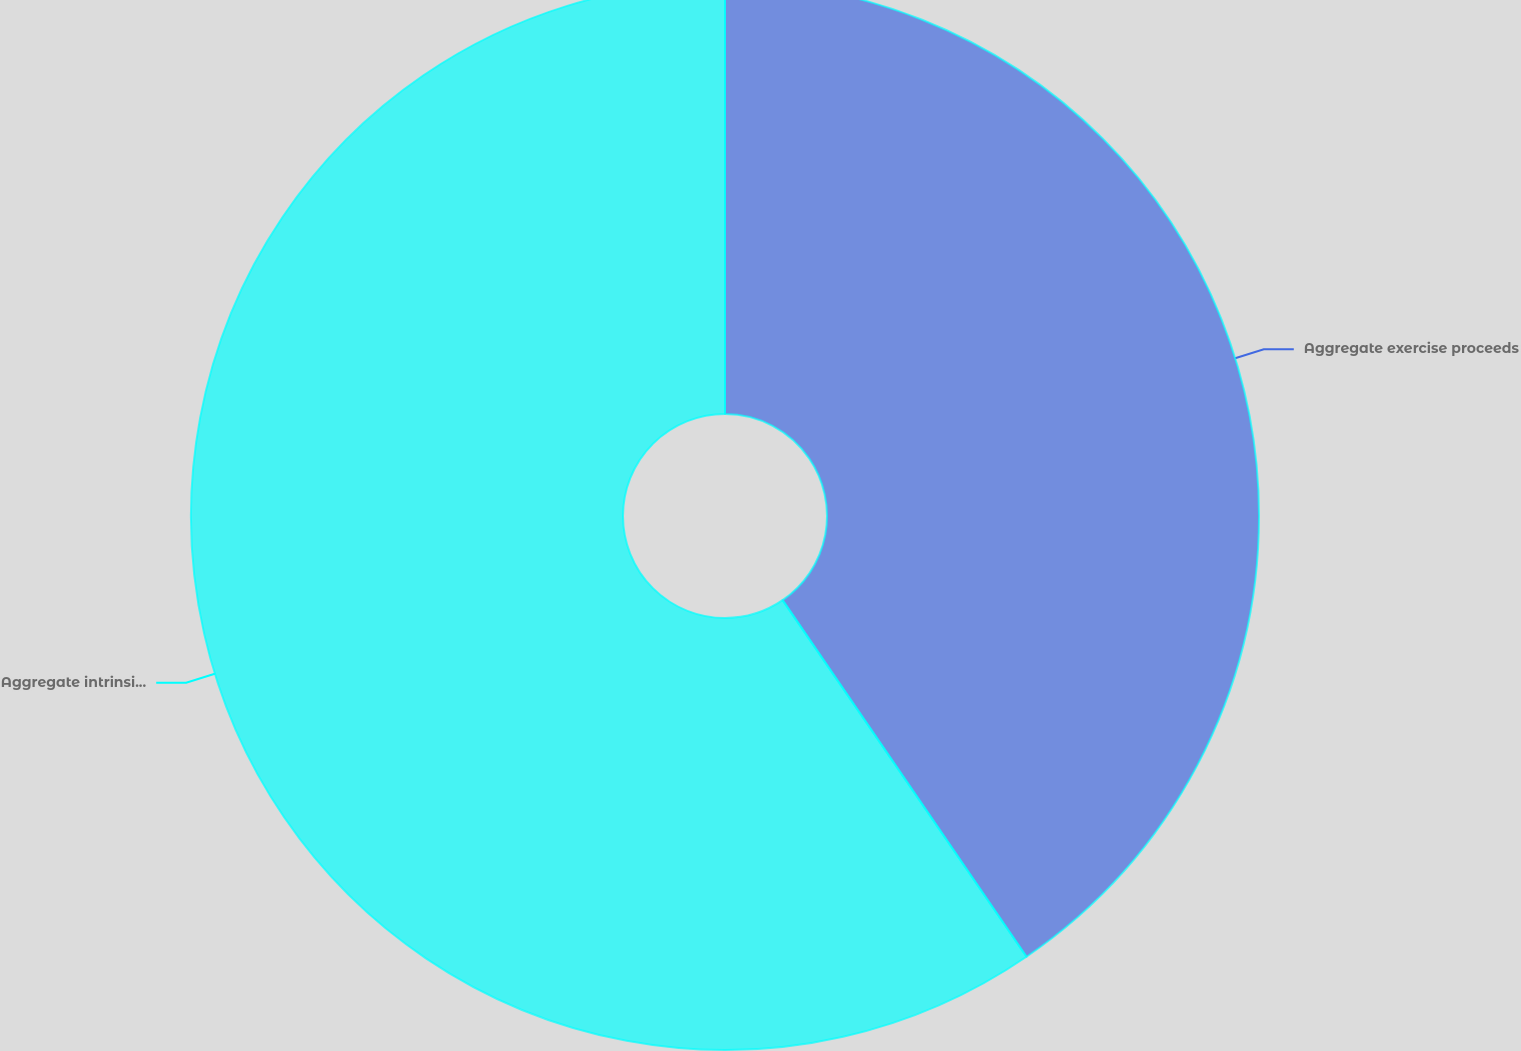Convert chart to OTSL. <chart><loc_0><loc_0><loc_500><loc_500><pie_chart><fcel>Aggregate exercise proceeds<fcel>Aggregate intrinsic value on<nl><fcel>40.45%<fcel>59.55%<nl></chart> 